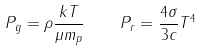Convert formula to latex. <formula><loc_0><loc_0><loc_500><loc_500>P _ { g } = \rho \frac { k T } { \mu m _ { p } } \quad P _ { r } = \frac { 4 \sigma } { 3 c } T ^ { 4 }</formula> 